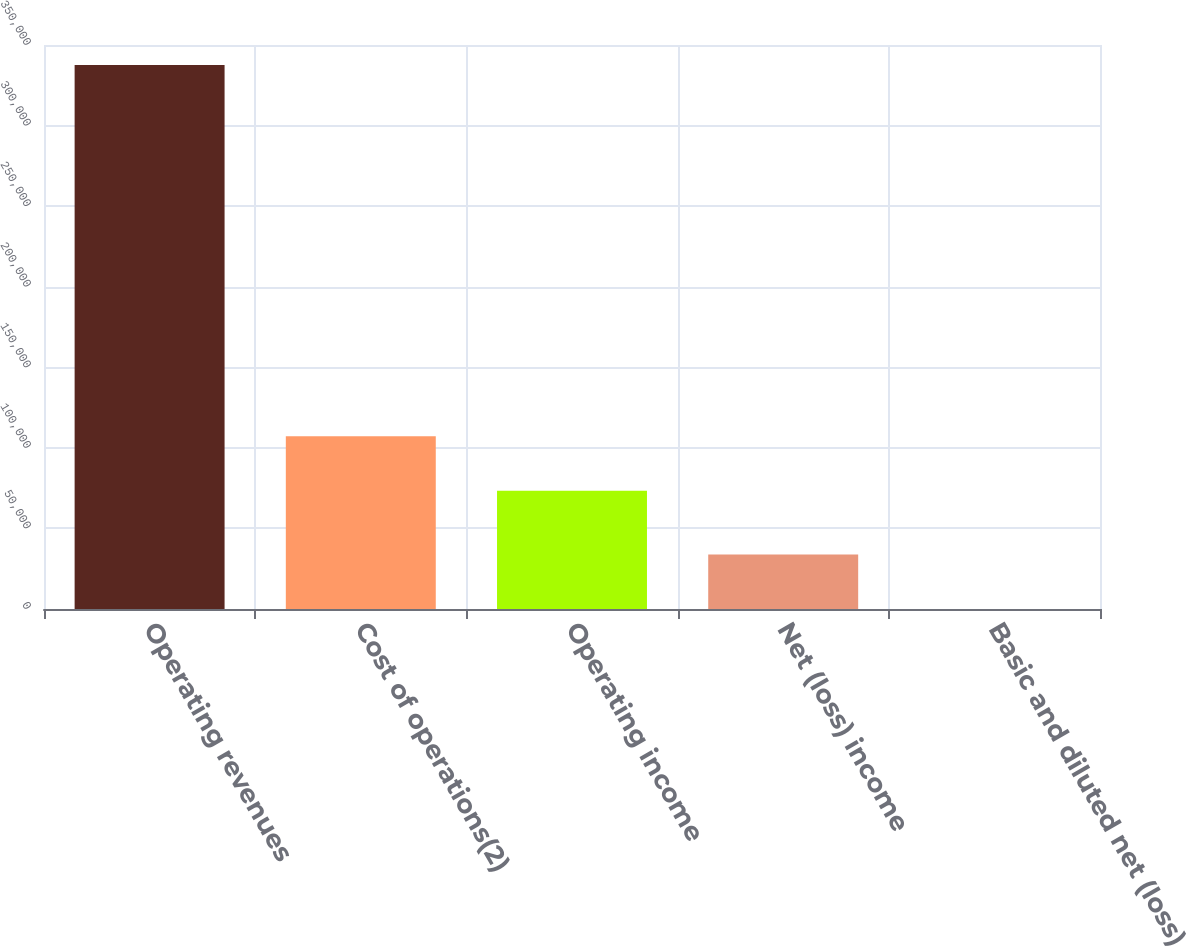Convert chart. <chart><loc_0><loc_0><loc_500><loc_500><bar_chart><fcel>Operating revenues<fcel>Cost of operations(2)<fcel>Operating income<fcel>Net (loss) income<fcel>Basic and diluted net (loss)<nl><fcel>337646<fcel>107178<fcel>73413<fcel>33764.6<fcel>0.04<nl></chart> 